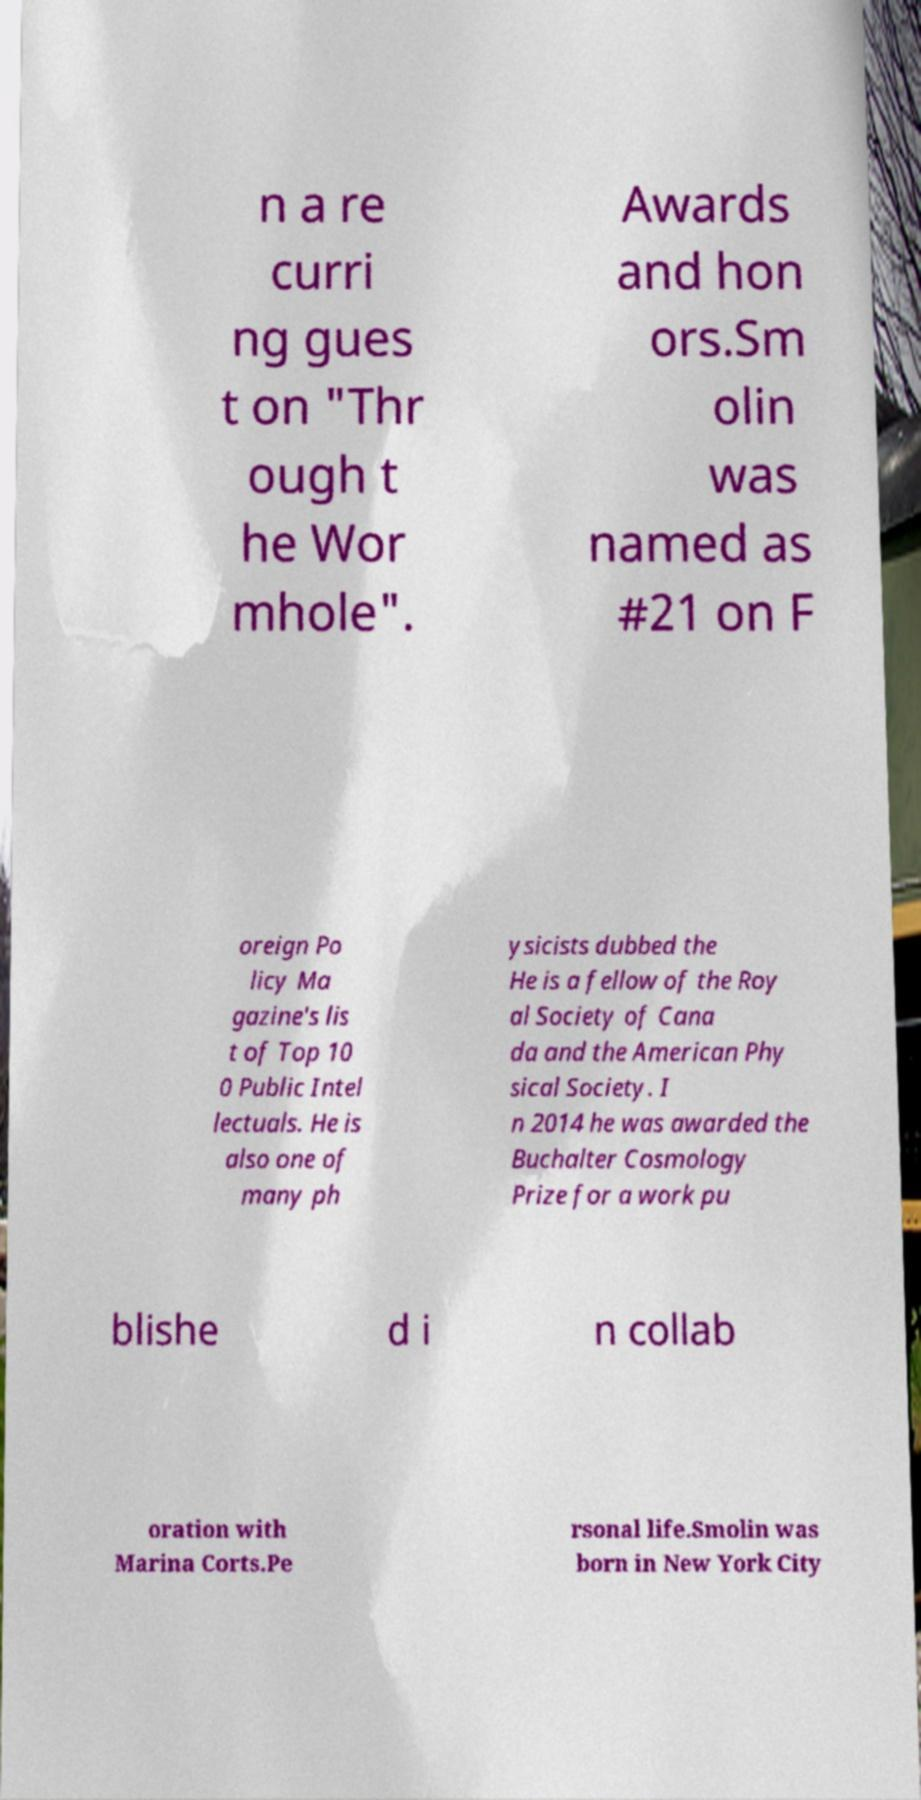Please identify and transcribe the text found in this image. n a re curri ng gues t on "Thr ough t he Wor mhole". Awards and hon ors.Sm olin was named as #21 on F oreign Po licy Ma gazine's lis t of Top 10 0 Public Intel lectuals. He is also one of many ph ysicists dubbed the He is a fellow of the Roy al Society of Cana da and the American Phy sical Society. I n 2014 he was awarded the Buchalter Cosmology Prize for a work pu blishe d i n collab oration with Marina Corts.Pe rsonal life.Smolin was born in New York City 